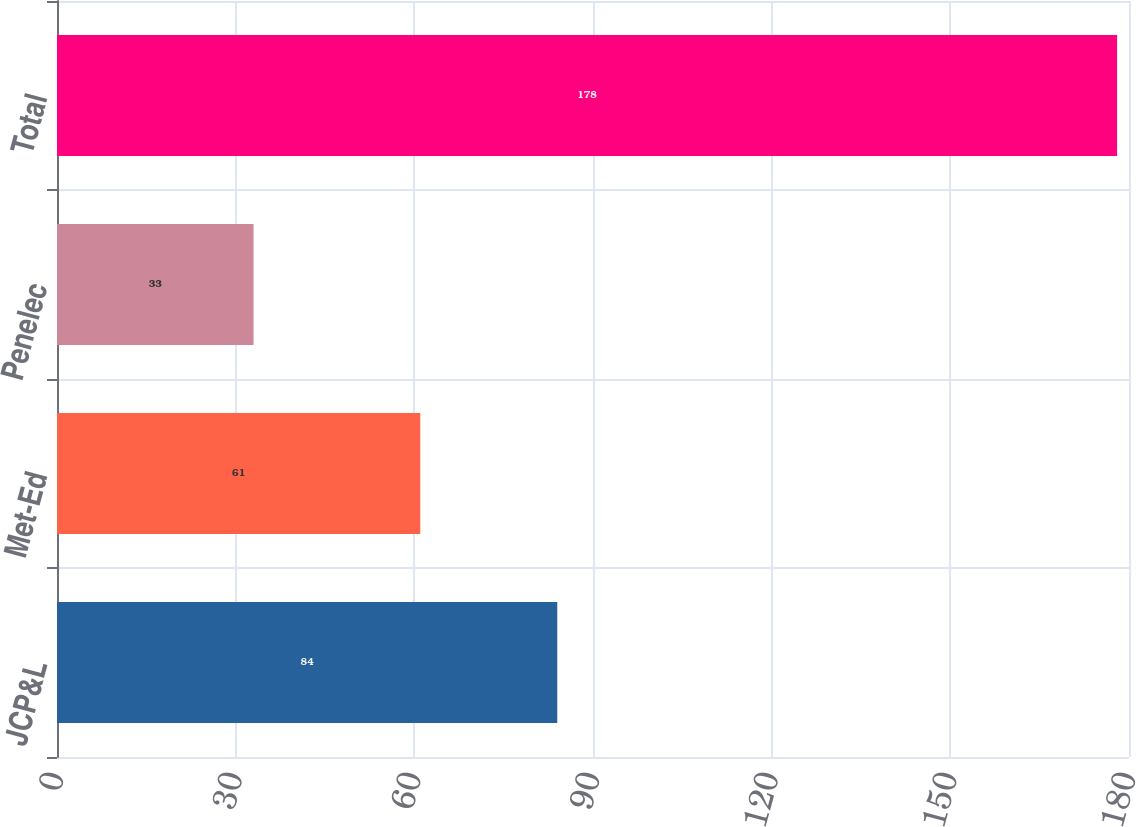<chart> <loc_0><loc_0><loc_500><loc_500><bar_chart><fcel>JCP&L<fcel>Met-Ed<fcel>Penelec<fcel>Total<nl><fcel>84<fcel>61<fcel>33<fcel>178<nl></chart> 